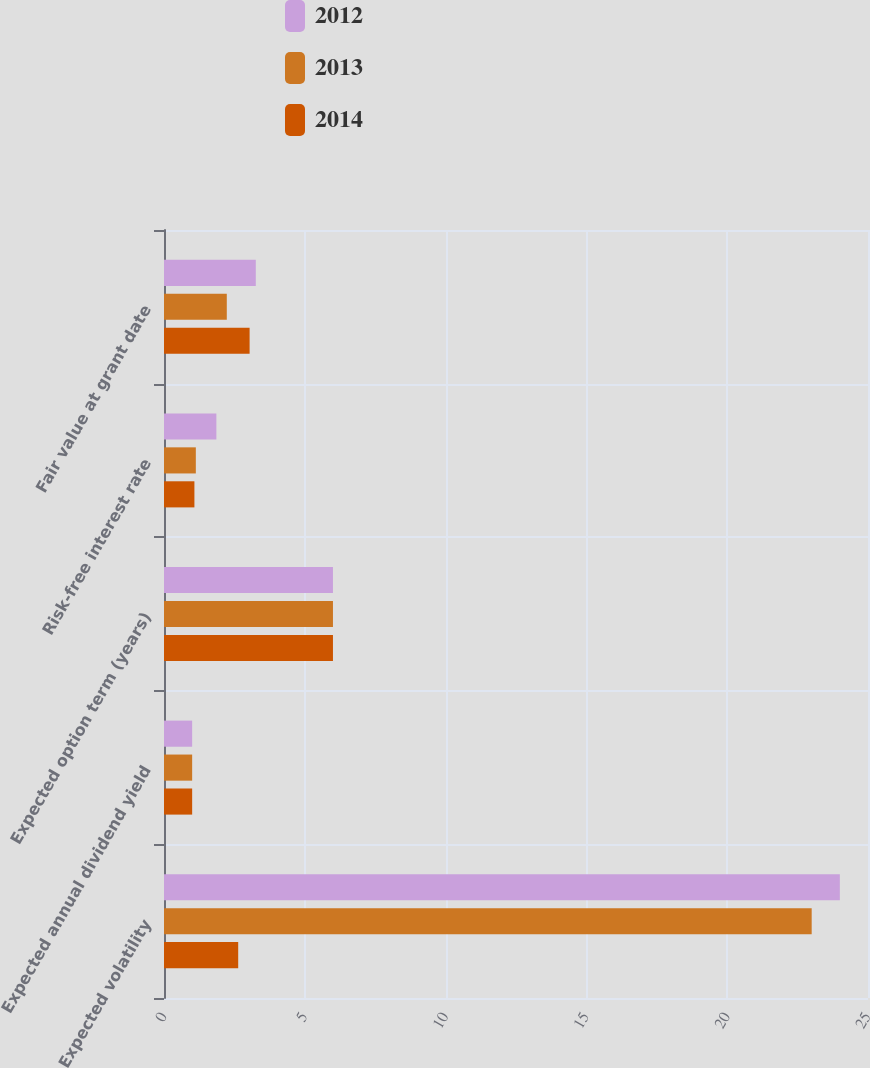Convert chart to OTSL. <chart><loc_0><loc_0><loc_500><loc_500><stacked_bar_chart><ecel><fcel>Expected volatility<fcel>Expected annual dividend yield<fcel>Expected option term (years)<fcel>Risk-free interest rate<fcel>Fair value at grant date<nl><fcel>2012<fcel>24<fcel>1<fcel>6<fcel>1.86<fcel>3.26<nl><fcel>2013<fcel>23<fcel>1<fcel>6<fcel>1.13<fcel>2.23<nl><fcel>2014<fcel>2.635<fcel>1<fcel>6<fcel>1.08<fcel>3.04<nl></chart> 